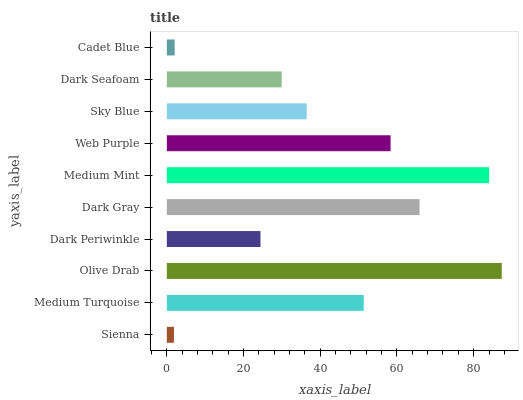Is Sienna the minimum?
Answer yes or no. Yes. Is Olive Drab the maximum?
Answer yes or no. Yes. Is Medium Turquoise the minimum?
Answer yes or no. No. Is Medium Turquoise the maximum?
Answer yes or no. No. Is Medium Turquoise greater than Sienna?
Answer yes or no. Yes. Is Sienna less than Medium Turquoise?
Answer yes or no. Yes. Is Sienna greater than Medium Turquoise?
Answer yes or no. No. Is Medium Turquoise less than Sienna?
Answer yes or no. No. Is Medium Turquoise the high median?
Answer yes or no. Yes. Is Sky Blue the low median?
Answer yes or no. Yes. Is Dark Gray the high median?
Answer yes or no. No. Is Dark Periwinkle the low median?
Answer yes or no. No. 